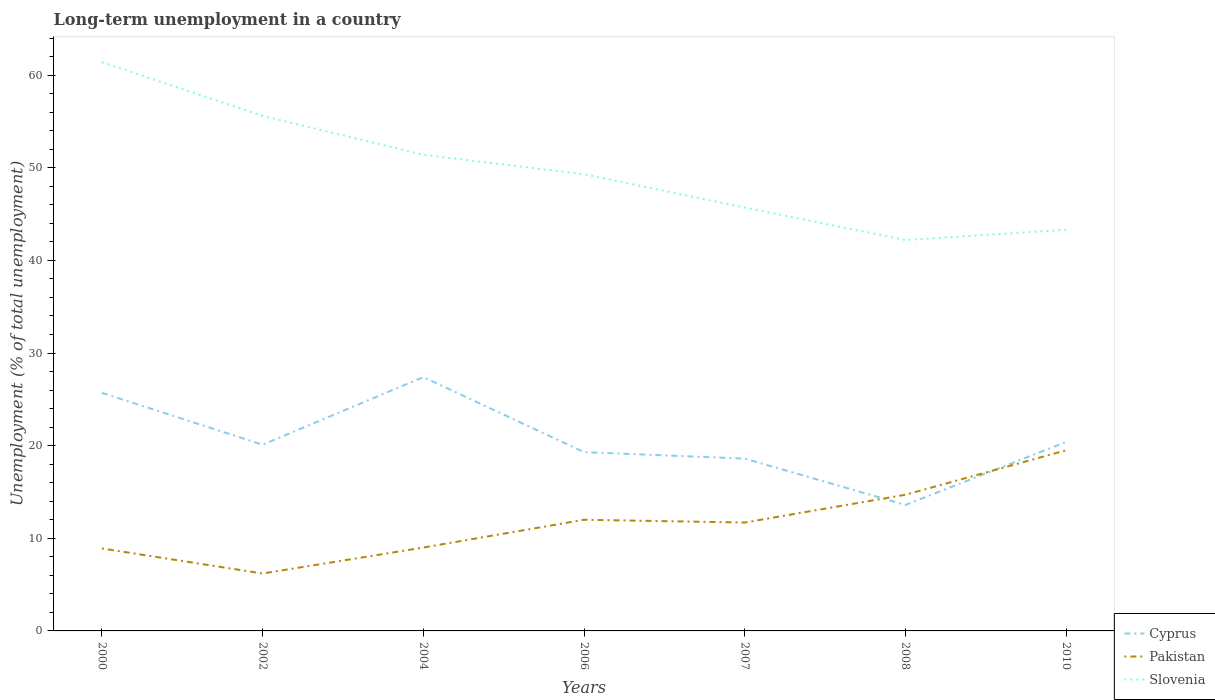How many different coloured lines are there?
Offer a terse response. 3. Does the line corresponding to Slovenia intersect with the line corresponding to Pakistan?
Your response must be concise. No. Is the number of lines equal to the number of legend labels?
Offer a terse response. Yes. Across all years, what is the maximum percentage of long-term unemployed population in Slovenia?
Keep it short and to the point. 42.2. What is the total percentage of long-term unemployed population in Pakistan in the graph?
Provide a succinct answer. -0.1. What is the difference between the highest and the second highest percentage of long-term unemployed population in Slovenia?
Your answer should be very brief. 19.2. What is the difference between two consecutive major ticks on the Y-axis?
Your answer should be very brief. 10. Are the values on the major ticks of Y-axis written in scientific E-notation?
Your response must be concise. No. Does the graph contain any zero values?
Provide a short and direct response. No. How many legend labels are there?
Offer a very short reply. 3. How are the legend labels stacked?
Keep it short and to the point. Vertical. What is the title of the graph?
Offer a very short reply. Long-term unemployment in a country. Does "Australia" appear as one of the legend labels in the graph?
Your answer should be compact. No. What is the label or title of the Y-axis?
Offer a very short reply. Unemployment (% of total unemployment). What is the Unemployment (% of total unemployment) of Cyprus in 2000?
Provide a succinct answer. 25.7. What is the Unemployment (% of total unemployment) of Pakistan in 2000?
Provide a succinct answer. 8.9. What is the Unemployment (% of total unemployment) in Slovenia in 2000?
Give a very brief answer. 61.4. What is the Unemployment (% of total unemployment) in Cyprus in 2002?
Ensure brevity in your answer.  20.1. What is the Unemployment (% of total unemployment) in Pakistan in 2002?
Give a very brief answer. 6.2. What is the Unemployment (% of total unemployment) in Slovenia in 2002?
Keep it short and to the point. 55.6. What is the Unemployment (% of total unemployment) in Cyprus in 2004?
Keep it short and to the point. 27.4. What is the Unemployment (% of total unemployment) in Slovenia in 2004?
Offer a very short reply. 51.4. What is the Unemployment (% of total unemployment) in Cyprus in 2006?
Your answer should be compact. 19.3. What is the Unemployment (% of total unemployment) in Slovenia in 2006?
Ensure brevity in your answer.  49.3. What is the Unemployment (% of total unemployment) in Cyprus in 2007?
Your response must be concise. 18.6. What is the Unemployment (% of total unemployment) in Pakistan in 2007?
Your answer should be very brief. 11.7. What is the Unemployment (% of total unemployment) of Slovenia in 2007?
Offer a terse response. 45.7. What is the Unemployment (% of total unemployment) in Cyprus in 2008?
Your answer should be compact. 13.6. What is the Unemployment (% of total unemployment) in Pakistan in 2008?
Keep it short and to the point. 14.7. What is the Unemployment (% of total unemployment) of Slovenia in 2008?
Give a very brief answer. 42.2. What is the Unemployment (% of total unemployment) of Cyprus in 2010?
Give a very brief answer. 20.4. What is the Unemployment (% of total unemployment) of Slovenia in 2010?
Provide a short and direct response. 43.3. Across all years, what is the maximum Unemployment (% of total unemployment) of Cyprus?
Keep it short and to the point. 27.4. Across all years, what is the maximum Unemployment (% of total unemployment) of Pakistan?
Give a very brief answer. 19.5. Across all years, what is the maximum Unemployment (% of total unemployment) in Slovenia?
Keep it short and to the point. 61.4. Across all years, what is the minimum Unemployment (% of total unemployment) of Cyprus?
Offer a very short reply. 13.6. Across all years, what is the minimum Unemployment (% of total unemployment) in Pakistan?
Make the answer very short. 6.2. Across all years, what is the minimum Unemployment (% of total unemployment) in Slovenia?
Offer a very short reply. 42.2. What is the total Unemployment (% of total unemployment) of Cyprus in the graph?
Give a very brief answer. 145.1. What is the total Unemployment (% of total unemployment) in Pakistan in the graph?
Ensure brevity in your answer.  82. What is the total Unemployment (% of total unemployment) of Slovenia in the graph?
Provide a short and direct response. 348.9. What is the difference between the Unemployment (% of total unemployment) of Cyprus in 2000 and that in 2002?
Provide a short and direct response. 5.6. What is the difference between the Unemployment (% of total unemployment) of Slovenia in 2000 and that in 2002?
Your answer should be compact. 5.8. What is the difference between the Unemployment (% of total unemployment) in Cyprus in 2000 and that in 2004?
Offer a terse response. -1.7. What is the difference between the Unemployment (% of total unemployment) of Slovenia in 2000 and that in 2004?
Give a very brief answer. 10. What is the difference between the Unemployment (% of total unemployment) of Pakistan in 2000 and that in 2006?
Offer a very short reply. -3.1. What is the difference between the Unemployment (% of total unemployment) of Pakistan in 2000 and that in 2007?
Make the answer very short. -2.8. What is the difference between the Unemployment (% of total unemployment) in Slovenia in 2000 and that in 2008?
Keep it short and to the point. 19.2. What is the difference between the Unemployment (% of total unemployment) of Cyprus in 2002 and that in 2004?
Offer a terse response. -7.3. What is the difference between the Unemployment (% of total unemployment) in Slovenia in 2002 and that in 2004?
Give a very brief answer. 4.2. What is the difference between the Unemployment (% of total unemployment) in Pakistan in 2002 and that in 2006?
Provide a short and direct response. -5.8. What is the difference between the Unemployment (% of total unemployment) in Slovenia in 2002 and that in 2006?
Provide a short and direct response. 6.3. What is the difference between the Unemployment (% of total unemployment) of Pakistan in 2002 and that in 2008?
Your answer should be compact. -8.5. What is the difference between the Unemployment (% of total unemployment) in Slovenia in 2002 and that in 2008?
Your answer should be compact. 13.4. What is the difference between the Unemployment (% of total unemployment) of Cyprus in 2002 and that in 2010?
Your answer should be very brief. -0.3. What is the difference between the Unemployment (% of total unemployment) in Pakistan in 2002 and that in 2010?
Provide a short and direct response. -13.3. What is the difference between the Unemployment (% of total unemployment) in Cyprus in 2004 and that in 2006?
Your response must be concise. 8.1. What is the difference between the Unemployment (% of total unemployment) of Cyprus in 2004 and that in 2008?
Offer a very short reply. 13.8. What is the difference between the Unemployment (% of total unemployment) in Pakistan in 2004 and that in 2008?
Your answer should be compact. -5.7. What is the difference between the Unemployment (% of total unemployment) of Cyprus in 2004 and that in 2010?
Keep it short and to the point. 7. What is the difference between the Unemployment (% of total unemployment) in Pakistan in 2004 and that in 2010?
Ensure brevity in your answer.  -10.5. What is the difference between the Unemployment (% of total unemployment) in Pakistan in 2006 and that in 2007?
Offer a terse response. 0.3. What is the difference between the Unemployment (% of total unemployment) of Slovenia in 2006 and that in 2007?
Give a very brief answer. 3.6. What is the difference between the Unemployment (% of total unemployment) in Cyprus in 2006 and that in 2008?
Keep it short and to the point. 5.7. What is the difference between the Unemployment (% of total unemployment) of Pakistan in 2006 and that in 2008?
Your answer should be compact. -2.7. What is the difference between the Unemployment (% of total unemployment) in Cyprus in 2006 and that in 2010?
Your response must be concise. -1.1. What is the difference between the Unemployment (% of total unemployment) of Slovenia in 2006 and that in 2010?
Give a very brief answer. 6. What is the difference between the Unemployment (% of total unemployment) in Pakistan in 2007 and that in 2008?
Provide a short and direct response. -3. What is the difference between the Unemployment (% of total unemployment) of Slovenia in 2007 and that in 2008?
Offer a terse response. 3.5. What is the difference between the Unemployment (% of total unemployment) in Cyprus in 2007 and that in 2010?
Offer a terse response. -1.8. What is the difference between the Unemployment (% of total unemployment) in Slovenia in 2007 and that in 2010?
Offer a terse response. 2.4. What is the difference between the Unemployment (% of total unemployment) of Pakistan in 2008 and that in 2010?
Offer a terse response. -4.8. What is the difference between the Unemployment (% of total unemployment) in Slovenia in 2008 and that in 2010?
Your answer should be compact. -1.1. What is the difference between the Unemployment (% of total unemployment) of Cyprus in 2000 and the Unemployment (% of total unemployment) of Slovenia in 2002?
Offer a very short reply. -29.9. What is the difference between the Unemployment (% of total unemployment) in Pakistan in 2000 and the Unemployment (% of total unemployment) in Slovenia in 2002?
Your answer should be compact. -46.7. What is the difference between the Unemployment (% of total unemployment) in Cyprus in 2000 and the Unemployment (% of total unemployment) in Slovenia in 2004?
Your answer should be compact. -25.7. What is the difference between the Unemployment (% of total unemployment) in Pakistan in 2000 and the Unemployment (% of total unemployment) in Slovenia in 2004?
Offer a terse response. -42.5. What is the difference between the Unemployment (% of total unemployment) in Cyprus in 2000 and the Unemployment (% of total unemployment) in Pakistan in 2006?
Make the answer very short. 13.7. What is the difference between the Unemployment (% of total unemployment) of Cyprus in 2000 and the Unemployment (% of total unemployment) of Slovenia in 2006?
Your answer should be very brief. -23.6. What is the difference between the Unemployment (% of total unemployment) in Pakistan in 2000 and the Unemployment (% of total unemployment) in Slovenia in 2006?
Offer a very short reply. -40.4. What is the difference between the Unemployment (% of total unemployment) in Cyprus in 2000 and the Unemployment (% of total unemployment) in Pakistan in 2007?
Your answer should be compact. 14. What is the difference between the Unemployment (% of total unemployment) in Cyprus in 2000 and the Unemployment (% of total unemployment) in Slovenia in 2007?
Your answer should be compact. -20. What is the difference between the Unemployment (% of total unemployment) in Pakistan in 2000 and the Unemployment (% of total unemployment) in Slovenia in 2007?
Your answer should be very brief. -36.8. What is the difference between the Unemployment (% of total unemployment) in Cyprus in 2000 and the Unemployment (% of total unemployment) in Slovenia in 2008?
Your response must be concise. -16.5. What is the difference between the Unemployment (% of total unemployment) of Pakistan in 2000 and the Unemployment (% of total unemployment) of Slovenia in 2008?
Provide a succinct answer. -33.3. What is the difference between the Unemployment (% of total unemployment) in Cyprus in 2000 and the Unemployment (% of total unemployment) in Slovenia in 2010?
Your answer should be compact. -17.6. What is the difference between the Unemployment (% of total unemployment) of Pakistan in 2000 and the Unemployment (% of total unemployment) of Slovenia in 2010?
Offer a terse response. -34.4. What is the difference between the Unemployment (% of total unemployment) in Cyprus in 2002 and the Unemployment (% of total unemployment) in Slovenia in 2004?
Give a very brief answer. -31.3. What is the difference between the Unemployment (% of total unemployment) of Pakistan in 2002 and the Unemployment (% of total unemployment) of Slovenia in 2004?
Offer a terse response. -45.2. What is the difference between the Unemployment (% of total unemployment) in Cyprus in 2002 and the Unemployment (% of total unemployment) in Pakistan in 2006?
Make the answer very short. 8.1. What is the difference between the Unemployment (% of total unemployment) of Cyprus in 2002 and the Unemployment (% of total unemployment) of Slovenia in 2006?
Give a very brief answer. -29.2. What is the difference between the Unemployment (% of total unemployment) of Pakistan in 2002 and the Unemployment (% of total unemployment) of Slovenia in 2006?
Offer a very short reply. -43.1. What is the difference between the Unemployment (% of total unemployment) of Cyprus in 2002 and the Unemployment (% of total unemployment) of Slovenia in 2007?
Your answer should be very brief. -25.6. What is the difference between the Unemployment (% of total unemployment) of Pakistan in 2002 and the Unemployment (% of total unemployment) of Slovenia in 2007?
Make the answer very short. -39.5. What is the difference between the Unemployment (% of total unemployment) of Cyprus in 2002 and the Unemployment (% of total unemployment) of Pakistan in 2008?
Offer a terse response. 5.4. What is the difference between the Unemployment (% of total unemployment) in Cyprus in 2002 and the Unemployment (% of total unemployment) in Slovenia in 2008?
Ensure brevity in your answer.  -22.1. What is the difference between the Unemployment (% of total unemployment) in Pakistan in 2002 and the Unemployment (% of total unemployment) in Slovenia in 2008?
Make the answer very short. -36. What is the difference between the Unemployment (% of total unemployment) in Cyprus in 2002 and the Unemployment (% of total unemployment) in Slovenia in 2010?
Your answer should be very brief. -23.2. What is the difference between the Unemployment (% of total unemployment) in Pakistan in 2002 and the Unemployment (% of total unemployment) in Slovenia in 2010?
Offer a terse response. -37.1. What is the difference between the Unemployment (% of total unemployment) in Cyprus in 2004 and the Unemployment (% of total unemployment) in Slovenia in 2006?
Ensure brevity in your answer.  -21.9. What is the difference between the Unemployment (% of total unemployment) in Pakistan in 2004 and the Unemployment (% of total unemployment) in Slovenia in 2006?
Provide a short and direct response. -40.3. What is the difference between the Unemployment (% of total unemployment) in Cyprus in 2004 and the Unemployment (% of total unemployment) in Pakistan in 2007?
Ensure brevity in your answer.  15.7. What is the difference between the Unemployment (% of total unemployment) of Cyprus in 2004 and the Unemployment (% of total unemployment) of Slovenia in 2007?
Your answer should be very brief. -18.3. What is the difference between the Unemployment (% of total unemployment) of Pakistan in 2004 and the Unemployment (% of total unemployment) of Slovenia in 2007?
Make the answer very short. -36.7. What is the difference between the Unemployment (% of total unemployment) in Cyprus in 2004 and the Unemployment (% of total unemployment) in Pakistan in 2008?
Make the answer very short. 12.7. What is the difference between the Unemployment (% of total unemployment) in Cyprus in 2004 and the Unemployment (% of total unemployment) in Slovenia in 2008?
Ensure brevity in your answer.  -14.8. What is the difference between the Unemployment (% of total unemployment) in Pakistan in 2004 and the Unemployment (% of total unemployment) in Slovenia in 2008?
Provide a short and direct response. -33.2. What is the difference between the Unemployment (% of total unemployment) of Cyprus in 2004 and the Unemployment (% of total unemployment) of Pakistan in 2010?
Ensure brevity in your answer.  7.9. What is the difference between the Unemployment (% of total unemployment) in Cyprus in 2004 and the Unemployment (% of total unemployment) in Slovenia in 2010?
Provide a succinct answer. -15.9. What is the difference between the Unemployment (% of total unemployment) in Pakistan in 2004 and the Unemployment (% of total unemployment) in Slovenia in 2010?
Keep it short and to the point. -34.3. What is the difference between the Unemployment (% of total unemployment) in Cyprus in 2006 and the Unemployment (% of total unemployment) in Slovenia in 2007?
Offer a very short reply. -26.4. What is the difference between the Unemployment (% of total unemployment) in Pakistan in 2006 and the Unemployment (% of total unemployment) in Slovenia in 2007?
Provide a short and direct response. -33.7. What is the difference between the Unemployment (% of total unemployment) in Cyprus in 2006 and the Unemployment (% of total unemployment) in Slovenia in 2008?
Your answer should be compact. -22.9. What is the difference between the Unemployment (% of total unemployment) of Pakistan in 2006 and the Unemployment (% of total unemployment) of Slovenia in 2008?
Your answer should be very brief. -30.2. What is the difference between the Unemployment (% of total unemployment) in Cyprus in 2006 and the Unemployment (% of total unemployment) in Slovenia in 2010?
Ensure brevity in your answer.  -24. What is the difference between the Unemployment (% of total unemployment) in Pakistan in 2006 and the Unemployment (% of total unemployment) in Slovenia in 2010?
Offer a very short reply. -31.3. What is the difference between the Unemployment (% of total unemployment) in Cyprus in 2007 and the Unemployment (% of total unemployment) in Slovenia in 2008?
Offer a very short reply. -23.6. What is the difference between the Unemployment (% of total unemployment) in Pakistan in 2007 and the Unemployment (% of total unemployment) in Slovenia in 2008?
Provide a succinct answer. -30.5. What is the difference between the Unemployment (% of total unemployment) of Cyprus in 2007 and the Unemployment (% of total unemployment) of Pakistan in 2010?
Your answer should be compact. -0.9. What is the difference between the Unemployment (% of total unemployment) in Cyprus in 2007 and the Unemployment (% of total unemployment) in Slovenia in 2010?
Your response must be concise. -24.7. What is the difference between the Unemployment (% of total unemployment) of Pakistan in 2007 and the Unemployment (% of total unemployment) of Slovenia in 2010?
Keep it short and to the point. -31.6. What is the difference between the Unemployment (% of total unemployment) of Cyprus in 2008 and the Unemployment (% of total unemployment) of Pakistan in 2010?
Give a very brief answer. -5.9. What is the difference between the Unemployment (% of total unemployment) of Cyprus in 2008 and the Unemployment (% of total unemployment) of Slovenia in 2010?
Make the answer very short. -29.7. What is the difference between the Unemployment (% of total unemployment) in Pakistan in 2008 and the Unemployment (% of total unemployment) in Slovenia in 2010?
Your answer should be compact. -28.6. What is the average Unemployment (% of total unemployment) in Cyprus per year?
Ensure brevity in your answer.  20.73. What is the average Unemployment (% of total unemployment) in Pakistan per year?
Your response must be concise. 11.71. What is the average Unemployment (% of total unemployment) in Slovenia per year?
Keep it short and to the point. 49.84. In the year 2000, what is the difference between the Unemployment (% of total unemployment) in Cyprus and Unemployment (% of total unemployment) in Pakistan?
Your response must be concise. 16.8. In the year 2000, what is the difference between the Unemployment (% of total unemployment) in Cyprus and Unemployment (% of total unemployment) in Slovenia?
Provide a short and direct response. -35.7. In the year 2000, what is the difference between the Unemployment (% of total unemployment) in Pakistan and Unemployment (% of total unemployment) in Slovenia?
Provide a short and direct response. -52.5. In the year 2002, what is the difference between the Unemployment (% of total unemployment) of Cyprus and Unemployment (% of total unemployment) of Pakistan?
Provide a short and direct response. 13.9. In the year 2002, what is the difference between the Unemployment (% of total unemployment) of Cyprus and Unemployment (% of total unemployment) of Slovenia?
Your answer should be compact. -35.5. In the year 2002, what is the difference between the Unemployment (% of total unemployment) of Pakistan and Unemployment (% of total unemployment) of Slovenia?
Make the answer very short. -49.4. In the year 2004, what is the difference between the Unemployment (% of total unemployment) in Pakistan and Unemployment (% of total unemployment) in Slovenia?
Provide a succinct answer. -42.4. In the year 2006, what is the difference between the Unemployment (% of total unemployment) of Cyprus and Unemployment (% of total unemployment) of Pakistan?
Provide a succinct answer. 7.3. In the year 2006, what is the difference between the Unemployment (% of total unemployment) of Cyprus and Unemployment (% of total unemployment) of Slovenia?
Make the answer very short. -30. In the year 2006, what is the difference between the Unemployment (% of total unemployment) of Pakistan and Unemployment (% of total unemployment) of Slovenia?
Offer a terse response. -37.3. In the year 2007, what is the difference between the Unemployment (% of total unemployment) in Cyprus and Unemployment (% of total unemployment) in Slovenia?
Provide a short and direct response. -27.1. In the year 2007, what is the difference between the Unemployment (% of total unemployment) in Pakistan and Unemployment (% of total unemployment) in Slovenia?
Your response must be concise. -34. In the year 2008, what is the difference between the Unemployment (% of total unemployment) in Cyprus and Unemployment (% of total unemployment) in Slovenia?
Your answer should be very brief. -28.6. In the year 2008, what is the difference between the Unemployment (% of total unemployment) in Pakistan and Unemployment (% of total unemployment) in Slovenia?
Offer a very short reply. -27.5. In the year 2010, what is the difference between the Unemployment (% of total unemployment) of Cyprus and Unemployment (% of total unemployment) of Slovenia?
Your answer should be compact. -22.9. In the year 2010, what is the difference between the Unemployment (% of total unemployment) of Pakistan and Unemployment (% of total unemployment) of Slovenia?
Provide a short and direct response. -23.8. What is the ratio of the Unemployment (% of total unemployment) of Cyprus in 2000 to that in 2002?
Make the answer very short. 1.28. What is the ratio of the Unemployment (% of total unemployment) in Pakistan in 2000 to that in 2002?
Your answer should be very brief. 1.44. What is the ratio of the Unemployment (% of total unemployment) in Slovenia in 2000 to that in 2002?
Provide a succinct answer. 1.1. What is the ratio of the Unemployment (% of total unemployment) of Cyprus in 2000 to that in 2004?
Offer a terse response. 0.94. What is the ratio of the Unemployment (% of total unemployment) of Pakistan in 2000 to that in 2004?
Keep it short and to the point. 0.99. What is the ratio of the Unemployment (% of total unemployment) of Slovenia in 2000 to that in 2004?
Offer a very short reply. 1.19. What is the ratio of the Unemployment (% of total unemployment) in Cyprus in 2000 to that in 2006?
Give a very brief answer. 1.33. What is the ratio of the Unemployment (% of total unemployment) in Pakistan in 2000 to that in 2006?
Ensure brevity in your answer.  0.74. What is the ratio of the Unemployment (% of total unemployment) in Slovenia in 2000 to that in 2006?
Offer a very short reply. 1.25. What is the ratio of the Unemployment (% of total unemployment) of Cyprus in 2000 to that in 2007?
Offer a very short reply. 1.38. What is the ratio of the Unemployment (% of total unemployment) in Pakistan in 2000 to that in 2007?
Give a very brief answer. 0.76. What is the ratio of the Unemployment (% of total unemployment) of Slovenia in 2000 to that in 2007?
Give a very brief answer. 1.34. What is the ratio of the Unemployment (% of total unemployment) in Cyprus in 2000 to that in 2008?
Provide a succinct answer. 1.89. What is the ratio of the Unemployment (% of total unemployment) in Pakistan in 2000 to that in 2008?
Keep it short and to the point. 0.61. What is the ratio of the Unemployment (% of total unemployment) of Slovenia in 2000 to that in 2008?
Keep it short and to the point. 1.46. What is the ratio of the Unemployment (% of total unemployment) of Cyprus in 2000 to that in 2010?
Your answer should be very brief. 1.26. What is the ratio of the Unemployment (% of total unemployment) in Pakistan in 2000 to that in 2010?
Keep it short and to the point. 0.46. What is the ratio of the Unemployment (% of total unemployment) of Slovenia in 2000 to that in 2010?
Provide a short and direct response. 1.42. What is the ratio of the Unemployment (% of total unemployment) of Cyprus in 2002 to that in 2004?
Ensure brevity in your answer.  0.73. What is the ratio of the Unemployment (% of total unemployment) of Pakistan in 2002 to that in 2004?
Offer a terse response. 0.69. What is the ratio of the Unemployment (% of total unemployment) in Slovenia in 2002 to that in 2004?
Provide a succinct answer. 1.08. What is the ratio of the Unemployment (% of total unemployment) in Cyprus in 2002 to that in 2006?
Your answer should be very brief. 1.04. What is the ratio of the Unemployment (% of total unemployment) of Pakistan in 2002 to that in 2006?
Give a very brief answer. 0.52. What is the ratio of the Unemployment (% of total unemployment) in Slovenia in 2002 to that in 2006?
Your response must be concise. 1.13. What is the ratio of the Unemployment (% of total unemployment) of Cyprus in 2002 to that in 2007?
Offer a terse response. 1.08. What is the ratio of the Unemployment (% of total unemployment) in Pakistan in 2002 to that in 2007?
Your response must be concise. 0.53. What is the ratio of the Unemployment (% of total unemployment) of Slovenia in 2002 to that in 2007?
Your response must be concise. 1.22. What is the ratio of the Unemployment (% of total unemployment) of Cyprus in 2002 to that in 2008?
Give a very brief answer. 1.48. What is the ratio of the Unemployment (% of total unemployment) of Pakistan in 2002 to that in 2008?
Offer a terse response. 0.42. What is the ratio of the Unemployment (% of total unemployment) of Slovenia in 2002 to that in 2008?
Offer a terse response. 1.32. What is the ratio of the Unemployment (% of total unemployment) of Pakistan in 2002 to that in 2010?
Your response must be concise. 0.32. What is the ratio of the Unemployment (% of total unemployment) of Slovenia in 2002 to that in 2010?
Your response must be concise. 1.28. What is the ratio of the Unemployment (% of total unemployment) of Cyprus in 2004 to that in 2006?
Your response must be concise. 1.42. What is the ratio of the Unemployment (% of total unemployment) in Slovenia in 2004 to that in 2006?
Keep it short and to the point. 1.04. What is the ratio of the Unemployment (% of total unemployment) of Cyprus in 2004 to that in 2007?
Your answer should be very brief. 1.47. What is the ratio of the Unemployment (% of total unemployment) of Pakistan in 2004 to that in 2007?
Offer a very short reply. 0.77. What is the ratio of the Unemployment (% of total unemployment) of Slovenia in 2004 to that in 2007?
Your response must be concise. 1.12. What is the ratio of the Unemployment (% of total unemployment) of Cyprus in 2004 to that in 2008?
Ensure brevity in your answer.  2.01. What is the ratio of the Unemployment (% of total unemployment) in Pakistan in 2004 to that in 2008?
Keep it short and to the point. 0.61. What is the ratio of the Unemployment (% of total unemployment) of Slovenia in 2004 to that in 2008?
Offer a very short reply. 1.22. What is the ratio of the Unemployment (% of total unemployment) in Cyprus in 2004 to that in 2010?
Give a very brief answer. 1.34. What is the ratio of the Unemployment (% of total unemployment) in Pakistan in 2004 to that in 2010?
Your response must be concise. 0.46. What is the ratio of the Unemployment (% of total unemployment) of Slovenia in 2004 to that in 2010?
Give a very brief answer. 1.19. What is the ratio of the Unemployment (% of total unemployment) in Cyprus in 2006 to that in 2007?
Offer a terse response. 1.04. What is the ratio of the Unemployment (% of total unemployment) in Pakistan in 2006 to that in 2007?
Provide a succinct answer. 1.03. What is the ratio of the Unemployment (% of total unemployment) of Slovenia in 2006 to that in 2007?
Offer a terse response. 1.08. What is the ratio of the Unemployment (% of total unemployment) of Cyprus in 2006 to that in 2008?
Make the answer very short. 1.42. What is the ratio of the Unemployment (% of total unemployment) in Pakistan in 2006 to that in 2008?
Provide a succinct answer. 0.82. What is the ratio of the Unemployment (% of total unemployment) in Slovenia in 2006 to that in 2008?
Your response must be concise. 1.17. What is the ratio of the Unemployment (% of total unemployment) in Cyprus in 2006 to that in 2010?
Offer a very short reply. 0.95. What is the ratio of the Unemployment (% of total unemployment) in Pakistan in 2006 to that in 2010?
Offer a terse response. 0.62. What is the ratio of the Unemployment (% of total unemployment) of Slovenia in 2006 to that in 2010?
Provide a succinct answer. 1.14. What is the ratio of the Unemployment (% of total unemployment) of Cyprus in 2007 to that in 2008?
Keep it short and to the point. 1.37. What is the ratio of the Unemployment (% of total unemployment) of Pakistan in 2007 to that in 2008?
Your response must be concise. 0.8. What is the ratio of the Unemployment (% of total unemployment) in Slovenia in 2007 to that in 2008?
Your response must be concise. 1.08. What is the ratio of the Unemployment (% of total unemployment) of Cyprus in 2007 to that in 2010?
Your answer should be very brief. 0.91. What is the ratio of the Unemployment (% of total unemployment) of Pakistan in 2007 to that in 2010?
Offer a terse response. 0.6. What is the ratio of the Unemployment (% of total unemployment) of Slovenia in 2007 to that in 2010?
Provide a short and direct response. 1.06. What is the ratio of the Unemployment (% of total unemployment) of Pakistan in 2008 to that in 2010?
Your answer should be compact. 0.75. What is the ratio of the Unemployment (% of total unemployment) of Slovenia in 2008 to that in 2010?
Give a very brief answer. 0.97. What is the difference between the highest and the second highest Unemployment (% of total unemployment) in Pakistan?
Your answer should be very brief. 4.8. What is the difference between the highest and the second highest Unemployment (% of total unemployment) in Slovenia?
Provide a succinct answer. 5.8. What is the difference between the highest and the lowest Unemployment (% of total unemployment) of Pakistan?
Provide a succinct answer. 13.3. What is the difference between the highest and the lowest Unemployment (% of total unemployment) of Slovenia?
Keep it short and to the point. 19.2. 